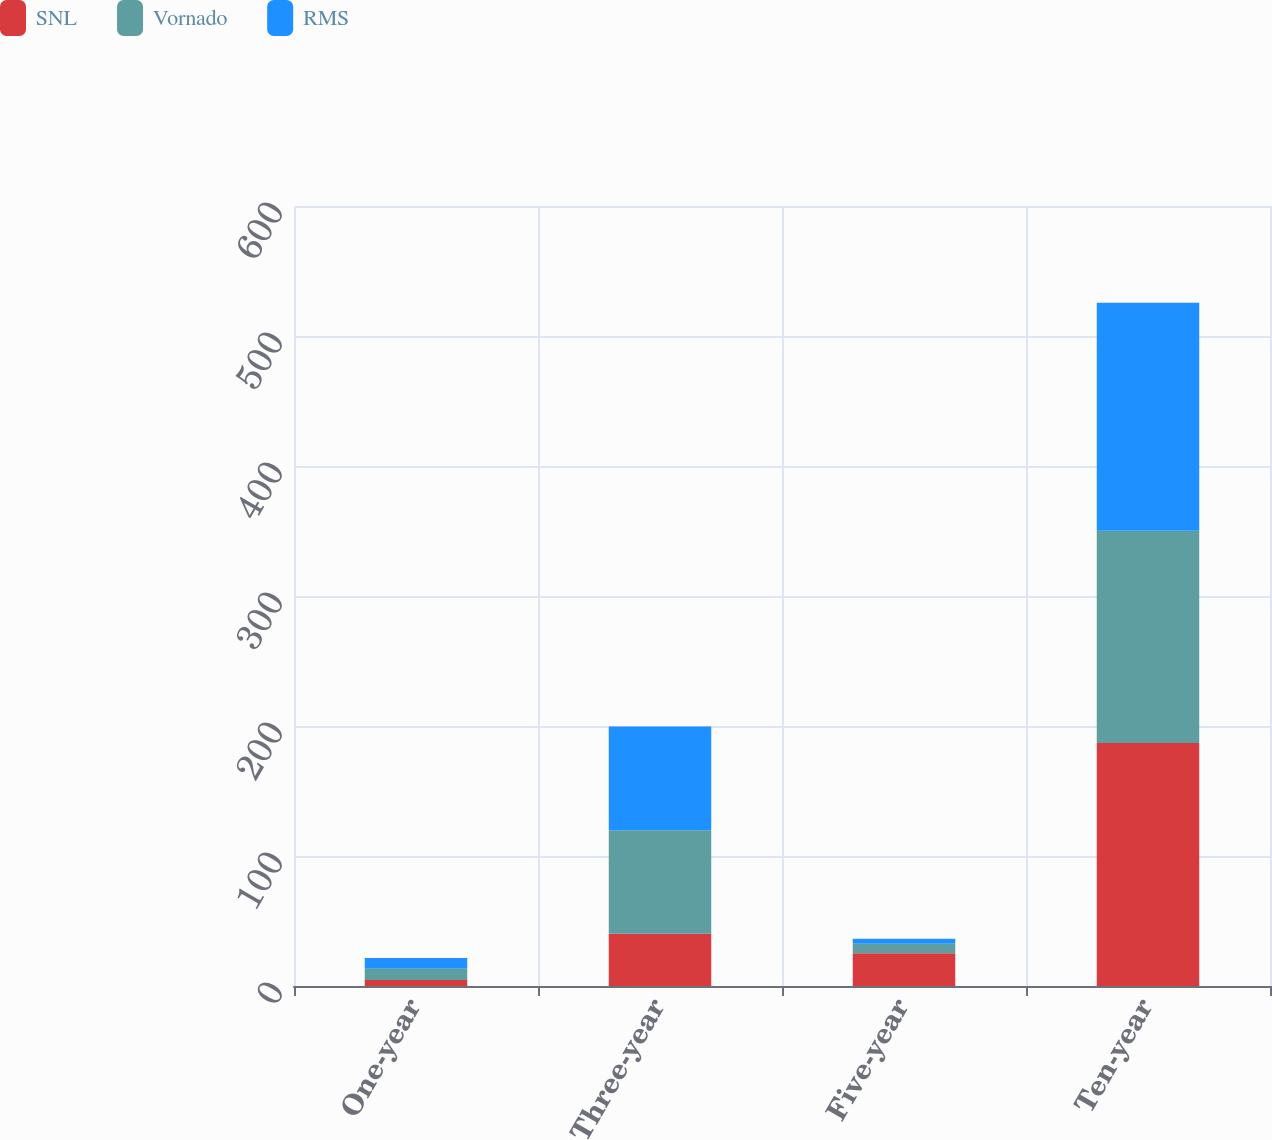<chart> <loc_0><loc_0><loc_500><loc_500><stacked_bar_chart><ecel><fcel>One-year<fcel>Three-year<fcel>Five-year<fcel>Ten-year<nl><fcel>SNL<fcel>4.6<fcel>40.2<fcel>25.2<fcel>187<nl><fcel>Vornado<fcel>8.7<fcel>79.6<fcel>7.3<fcel>163.2<nl><fcel>RMS<fcel>8.3<fcel>79.9<fcel>3.9<fcel>175.4<nl></chart> 